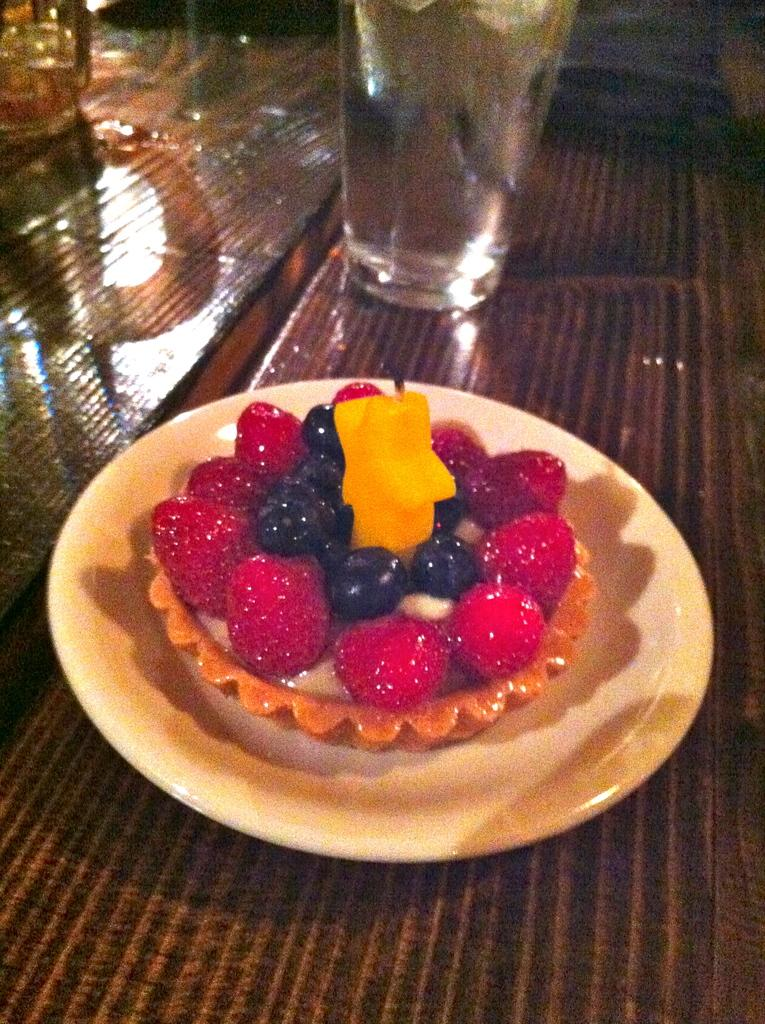What is on the plate that is visible in the image? There is a plate with food items in the image. What else can be seen on the table besides the plate? There are glasses visible in the image. Where are the plate and glasses located in the image? The plate and glasses are placed on a table. What sense does the father use to enjoy the food in the image? There is no father present in the image, and therefore no sense can be attributed to him. 